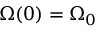Convert formula to latex. <formula><loc_0><loc_0><loc_500><loc_500>{ \boldsymbol \Omega } ( 0 ) = { \boldsymbol \Omega } _ { 0 }</formula> 